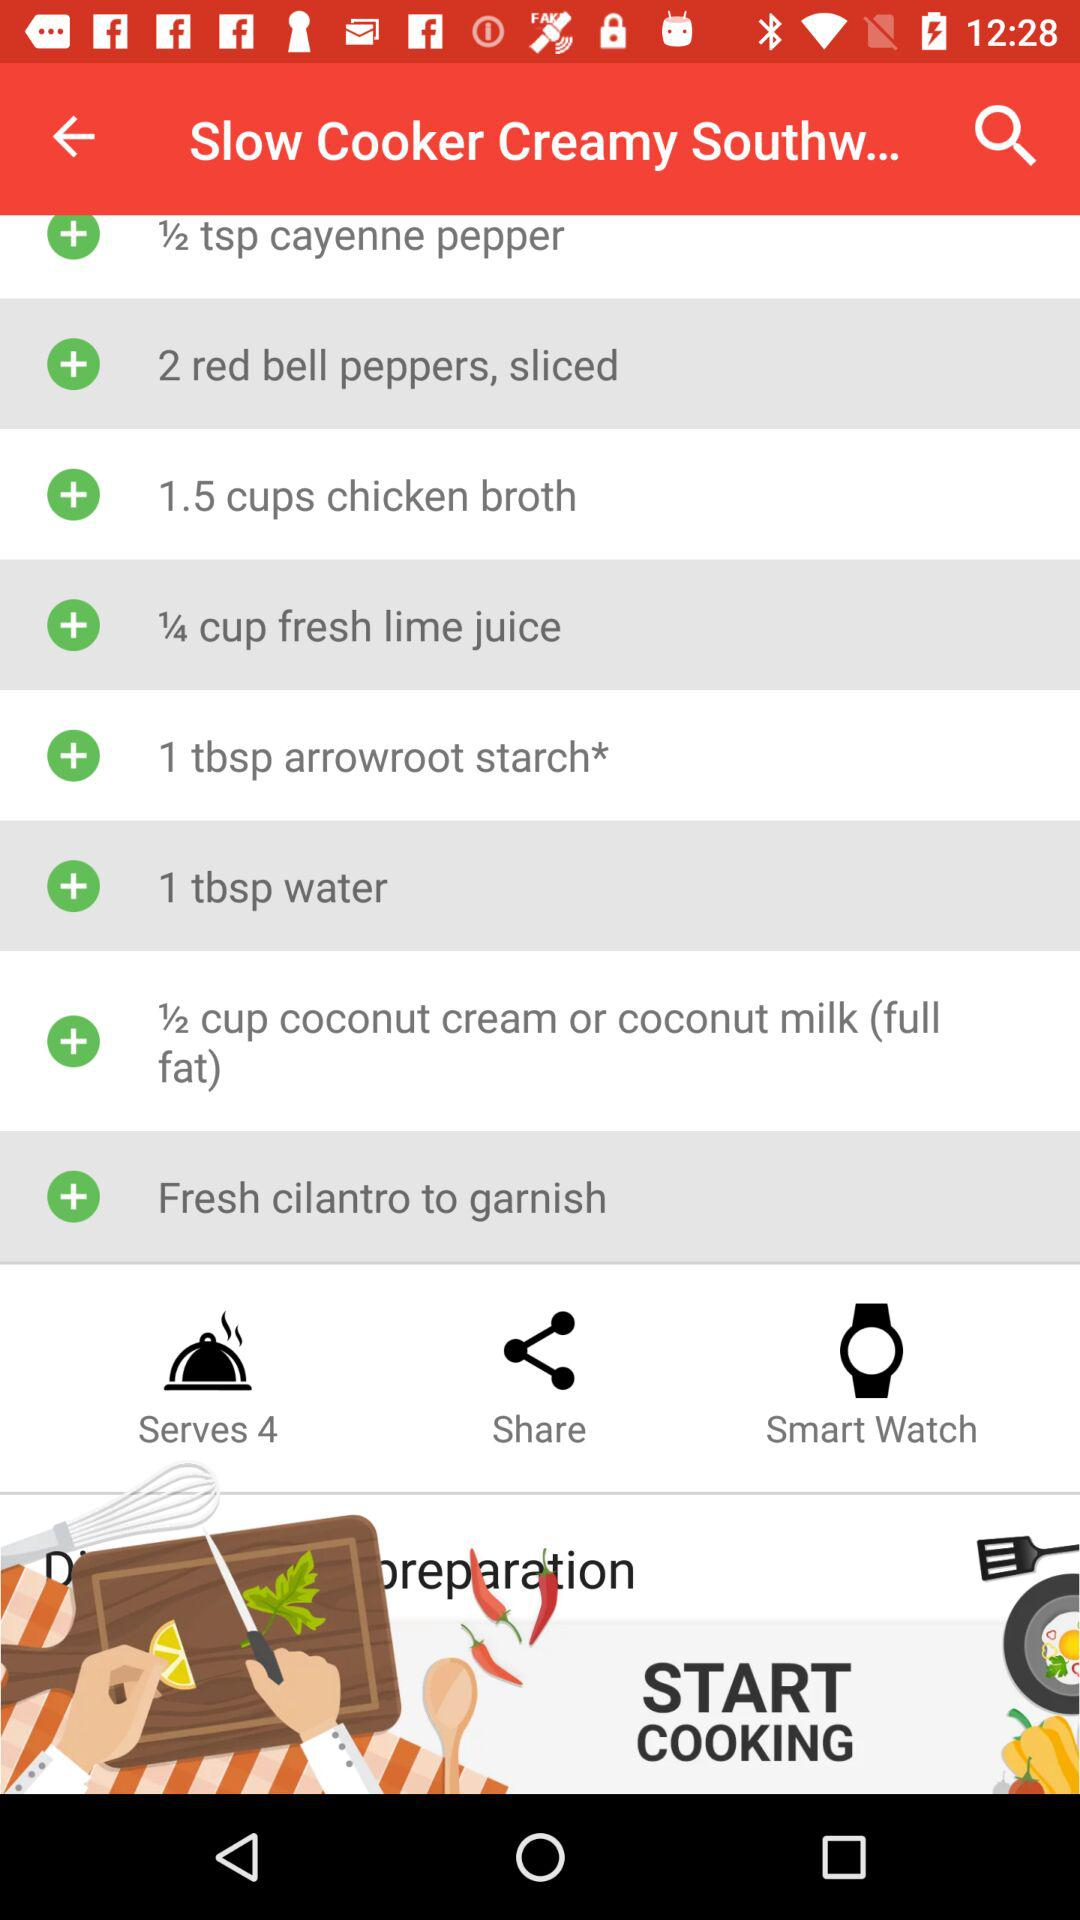How many servings are there in the dish? There are 4 servings in the dish. 